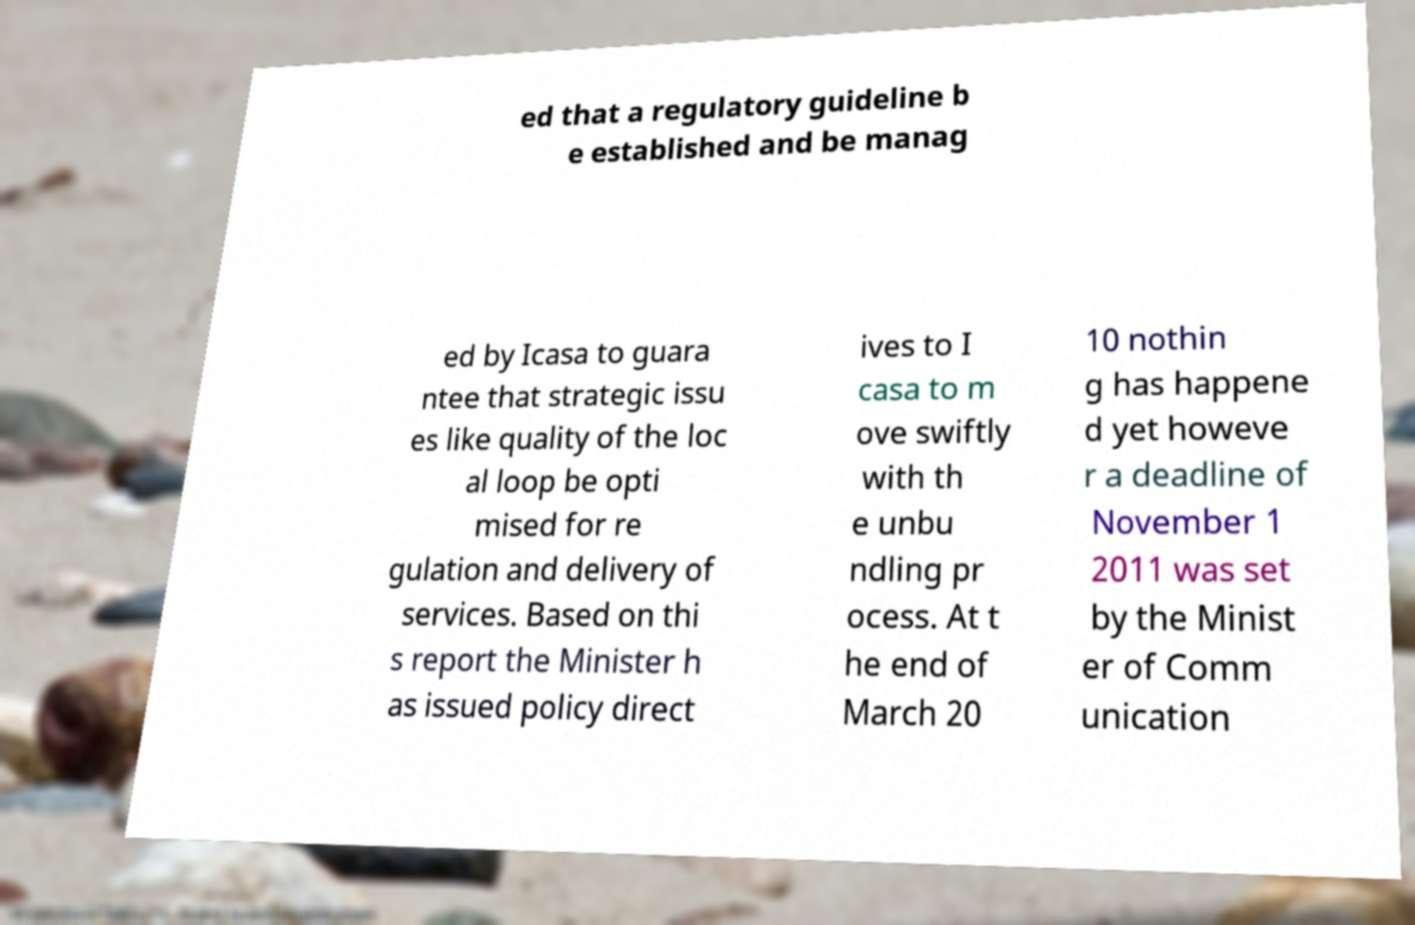What messages or text are displayed in this image? I need them in a readable, typed format. ed that a regulatory guideline b e established and be manag ed by Icasa to guara ntee that strategic issu es like quality of the loc al loop be opti mised for re gulation and delivery of services. Based on thi s report the Minister h as issued policy direct ives to I casa to m ove swiftly with th e unbu ndling pr ocess. At t he end of March 20 10 nothin g has happene d yet howeve r a deadline of November 1 2011 was set by the Minist er of Comm unication 